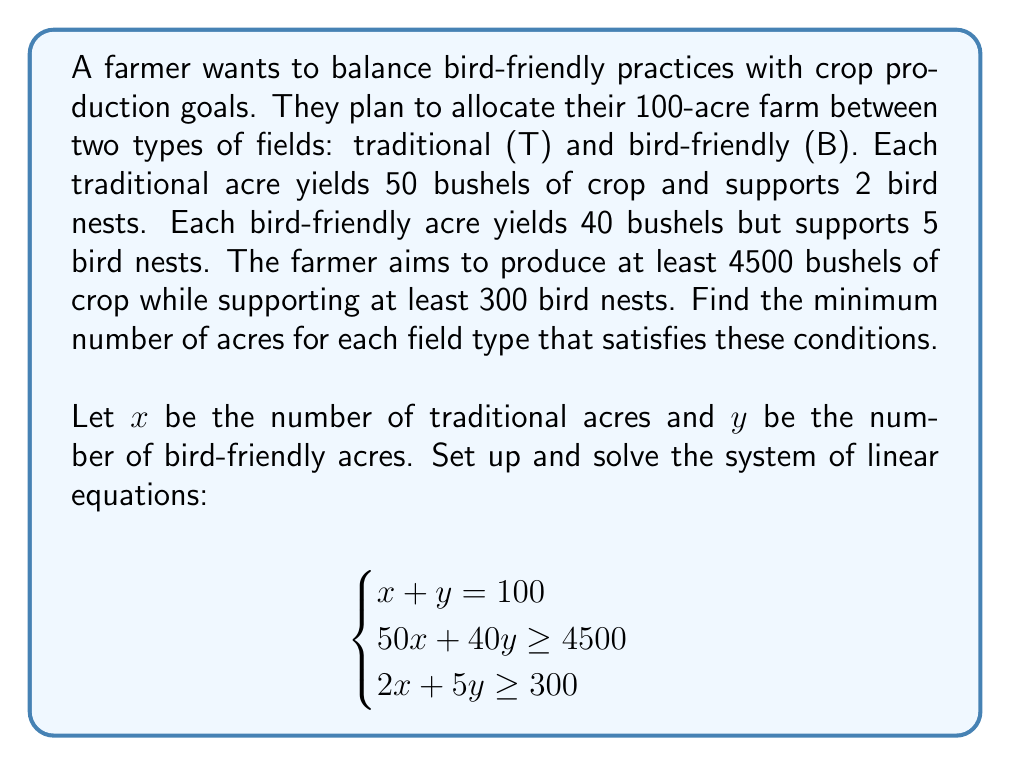Show me your answer to this math problem. Let's solve this system of linear equations step by step:

1) We have three constraints:
   a) $x + y = 100$ (total acreage)
   b) $50x + 40y \geq 4500$ (crop yield)
   c) $2x + 5y \geq 300$ (bird nests)

2) From constraint (a), we can express $y$ in terms of $x$:
   $y = 100 - x$

3) Substitute this into constraints (b) and (c):
   b) $50x + 40(100 - x) \geq 4500$
      $50x + 4000 - 40x \geq 4500$
      $10x \geq 500$
      $x \geq 50$

   c) $2x + 5(100 - x) \geq 300$
      $2x + 500 - 5x \geq 300$
      $-3x \geq -200$
      $x \leq 66.67$

4) Combining these results:
   $50 \leq x \leq 66.67$

5) Since we want the minimum number of traditional acres, we choose $x = 50$.

6) Substituting back into $y = 100 - x$:
   $y = 100 - 50 = 50$

7) Verify the solution satisfies all constraints:
   a) $50 + 50 = 100$ ✓
   b) $50(50) + 40(50) = 4500$ ✓
   c) $2(50) + 5(50) = 350 \geq 300$ ✓

Therefore, the minimum allocation that satisfies all conditions is 50 acres for each field type.
Answer: 50 acres traditional, 50 acres bird-friendly 